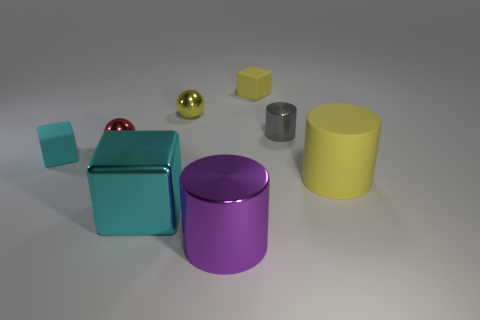How many other objects are the same color as the tiny metal cylinder?
Offer a very short reply. 0. Are the tiny cylinder and the sphere right of the red metal object made of the same material?
Ensure brevity in your answer.  Yes. There is a small rubber cube that is behind the yellow thing that is left of the purple metal thing; what number of rubber objects are in front of it?
Your response must be concise. 2. Is the number of cyan blocks to the left of the rubber cylinder less than the number of cylinders to the right of the red shiny object?
Your answer should be compact. Yes. How many other things are made of the same material as the red ball?
Your answer should be compact. 4. There is a purple thing that is the same size as the cyan shiny cube; what is it made of?
Your response must be concise. Metal. How many blue things are matte cylinders or small metallic spheres?
Give a very brief answer. 0. The rubber thing that is to the left of the large yellow cylinder and in front of the red shiny ball is what color?
Give a very brief answer. Cyan. Does the tiny block on the left side of the big purple object have the same material as the tiny yellow object that is to the left of the purple metallic thing?
Ensure brevity in your answer.  No. Are there more cyan matte cubes left of the yellow rubber cube than yellow matte cubes that are in front of the large purple metal object?
Your answer should be compact. Yes. 